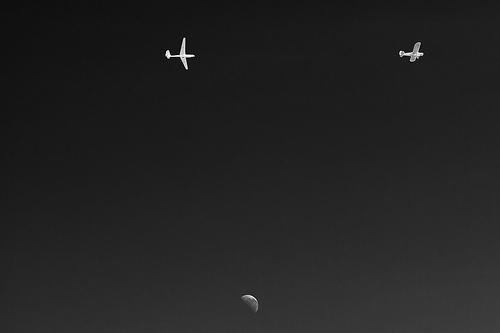Question: when was this picture taken?
Choices:
A. At night.
B. Daytime.
C. Dusk.
D. Dawn.
Answer with the letter. Answer: A Question: what is at the bottom of the picture?
Choices:
A. The moon.
B. Grass.
C. Stones.
D. Fish.
Answer with the letter. Answer: A Question: what is in the sky?
Choices:
A. Kites.
B. Balloons.
C. Birds.
D. Airplanes.
Answer with the letter. Answer: D Question: why is it dark?
Choices:
A. It's outer space.
B. It is night time.
C. It's midnight.
D. It's 2 A.M.
Answer with the letter. Answer: B 